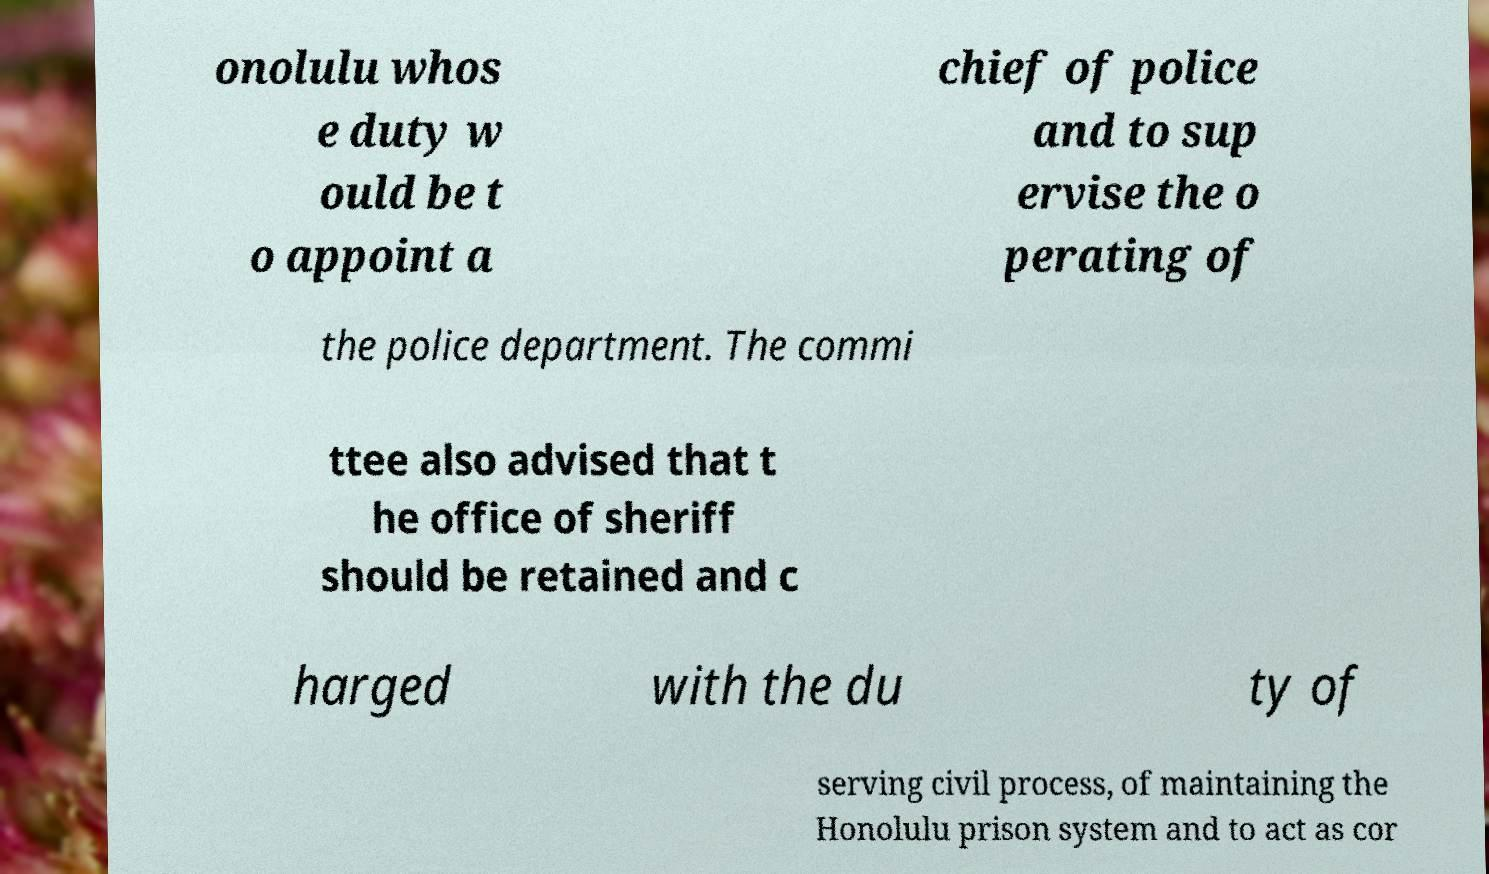For documentation purposes, I need the text within this image transcribed. Could you provide that? onolulu whos e duty w ould be t o appoint a chief of police and to sup ervise the o perating of the police department. The commi ttee also advised that t he office of sheriff should be retained and c harged with the du ty of serving civil process, of maintaining the Honolulu prison system and to act as cor 